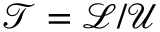<formula> <loc_0><loc_0><loc_500><loc_500>\mathcal { T } = \mathcal { L } / \mathcal { U }</formula> 